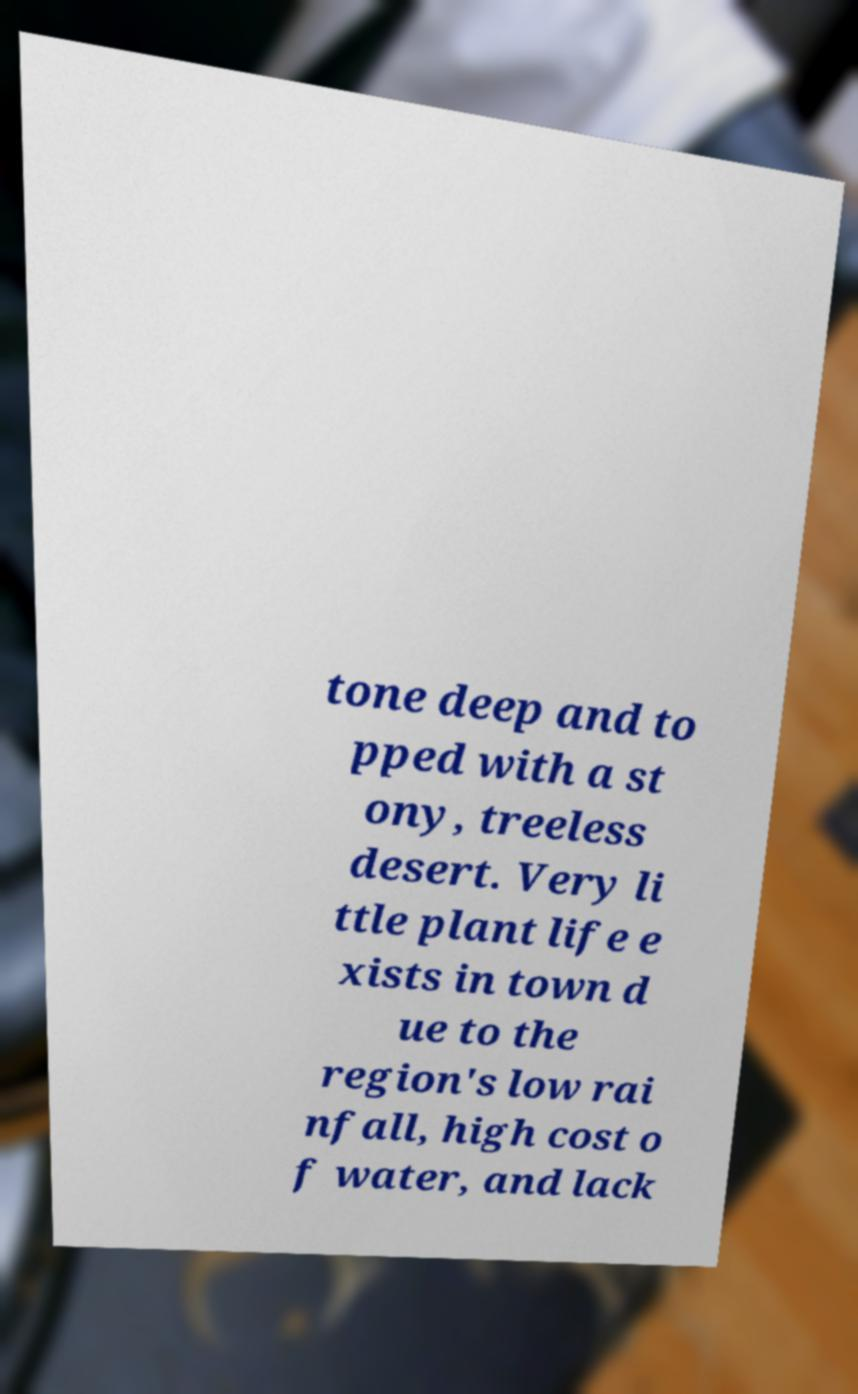There's text embedded in this image that I need extracted. Can you transcribe it verbatim? tone deep and to pped with a st ony, treeless desert. Very li ttle plant life e xists in town d ue to the region's low rai nfall, high cost o f water, and lack 